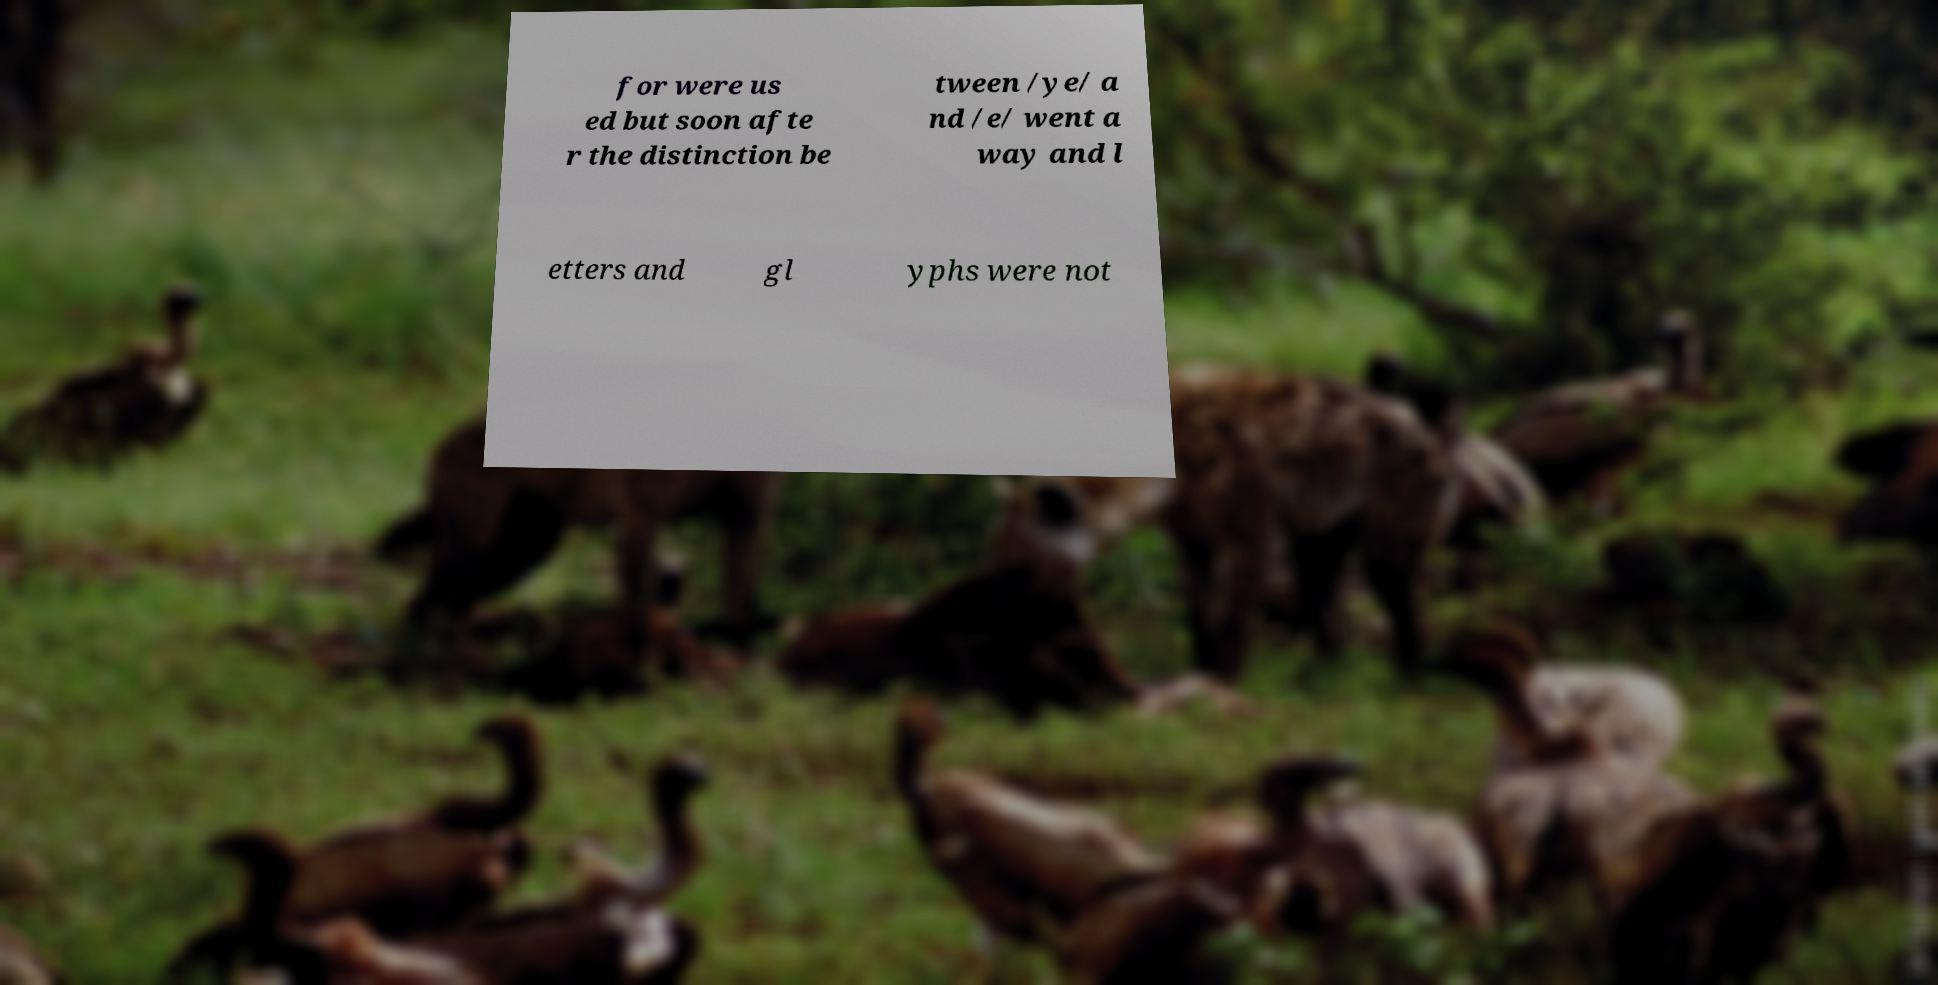Can you read and provide the text displayed in the image?This photo seems to have some interesting text. Can you extract and type it out for me? for were us ed but soon afte r the distinction be tween /ye/ a nd /e/ went a way and l etters and gl yphs were not 